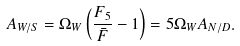Convert formula to latex. <formula><loc_0><loc_0><loc_500><loc_500>A _ { W / S } = \Omega _ { W } \left ( \frac { F _ { 5 } } { \bar { F } } - 1 \right ) = 5 \Omega _ { W } A _ { N / D } .</formula> 